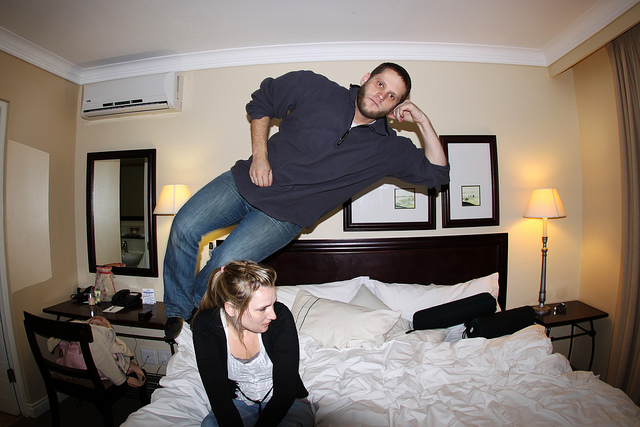What emotions do the people in the photo seem to be feeling? The individual who is 'floating' exudes a sense of carefree playfulness, with a relaxed posture and a contemplative hand position. The person sitting on the bed appears to be amused and delighted by the playful antics, judging by their open body language and focused attention on the 'floating' person. 